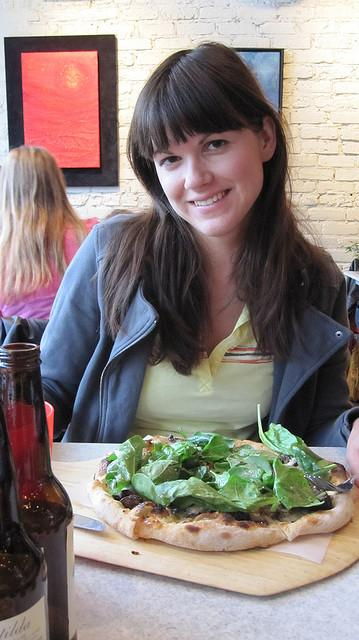What is adorning the pizza? Please explain your reasoning. lettuce. The pizza has lettuce. 